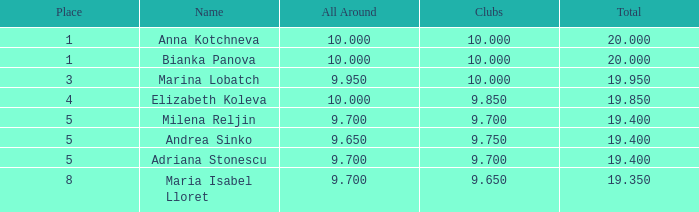What is the greatest cumulative amount bearing andrea sinko's name, with a total exceeding None. 